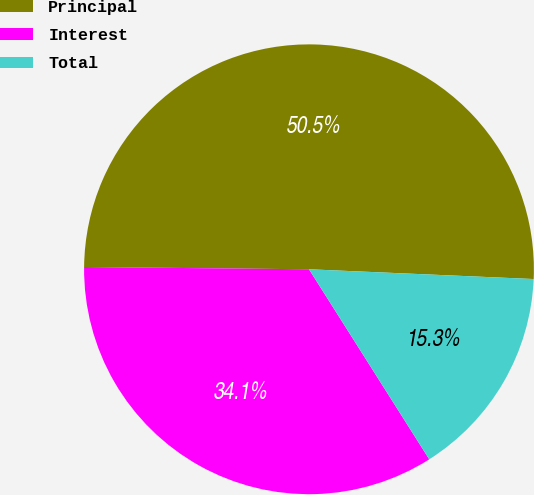Convert chart to OTSL. <chart><loc_0><loc_0><loc_500><loc_500><pie_chart><fcel>Principal<fcel>Interest<fcel>Total<nl><fcel>50.53%<fcel>34.14%<fcel>15.33%<nl></chart> 